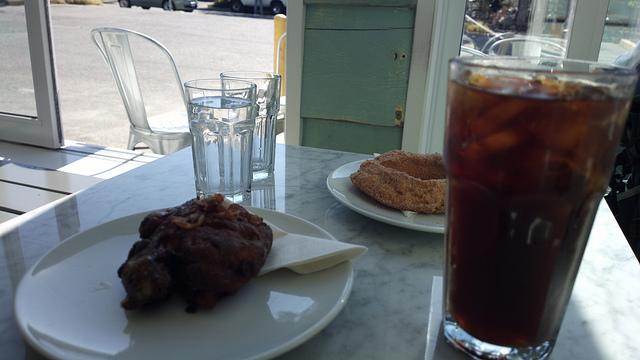Are any of the cups all the way full?
Quick response, please. Yes. Is there ice in the glass?
Give a very brief answer. Yes. What is the color of the plates?
Give a very brief answer. White. Is the drink alcoholic?
Keep it brief. No. Is the glass of water filled to the top?
Keep it brief. No. 